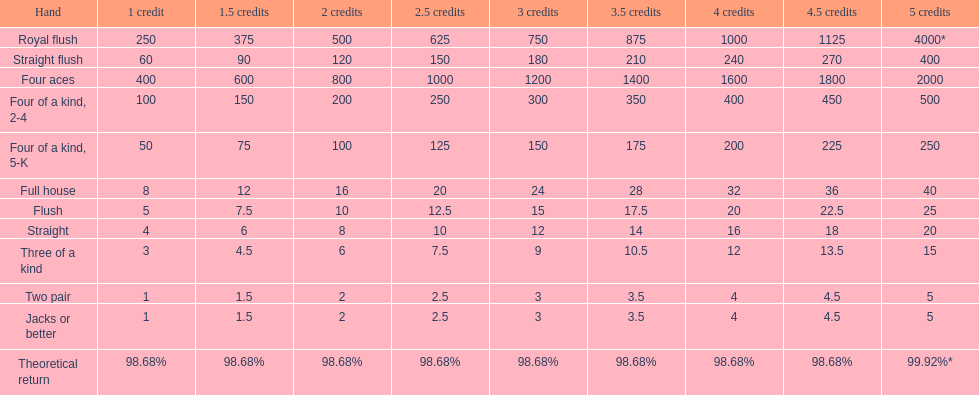After winning on four credits with a full house, what is your payout? 32. 